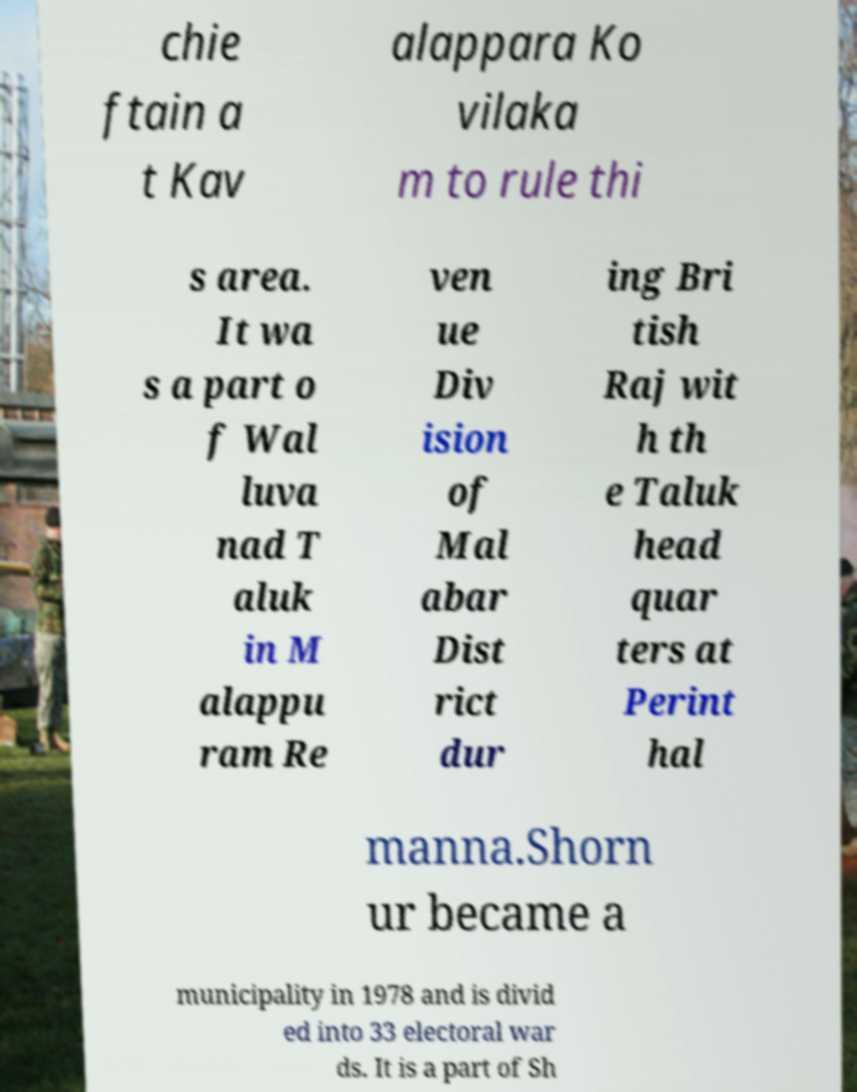Could you assist in decoding the text presented in this image and type it out clearly? chie ftain a t Kav alappara Ko vilaka m to rule thi s area. It wa s a part o f Wal luva nad T aluk in M alappu ram Re ven ue Div ision of Mal abar Dist rict dur ing Bri tish Raj wit h th e Taluk head quar ters at Perint hal manna.Shorn ur became a municipality in 1978 and is divid ed into 33 electoral war ds. It is a part of Sh 